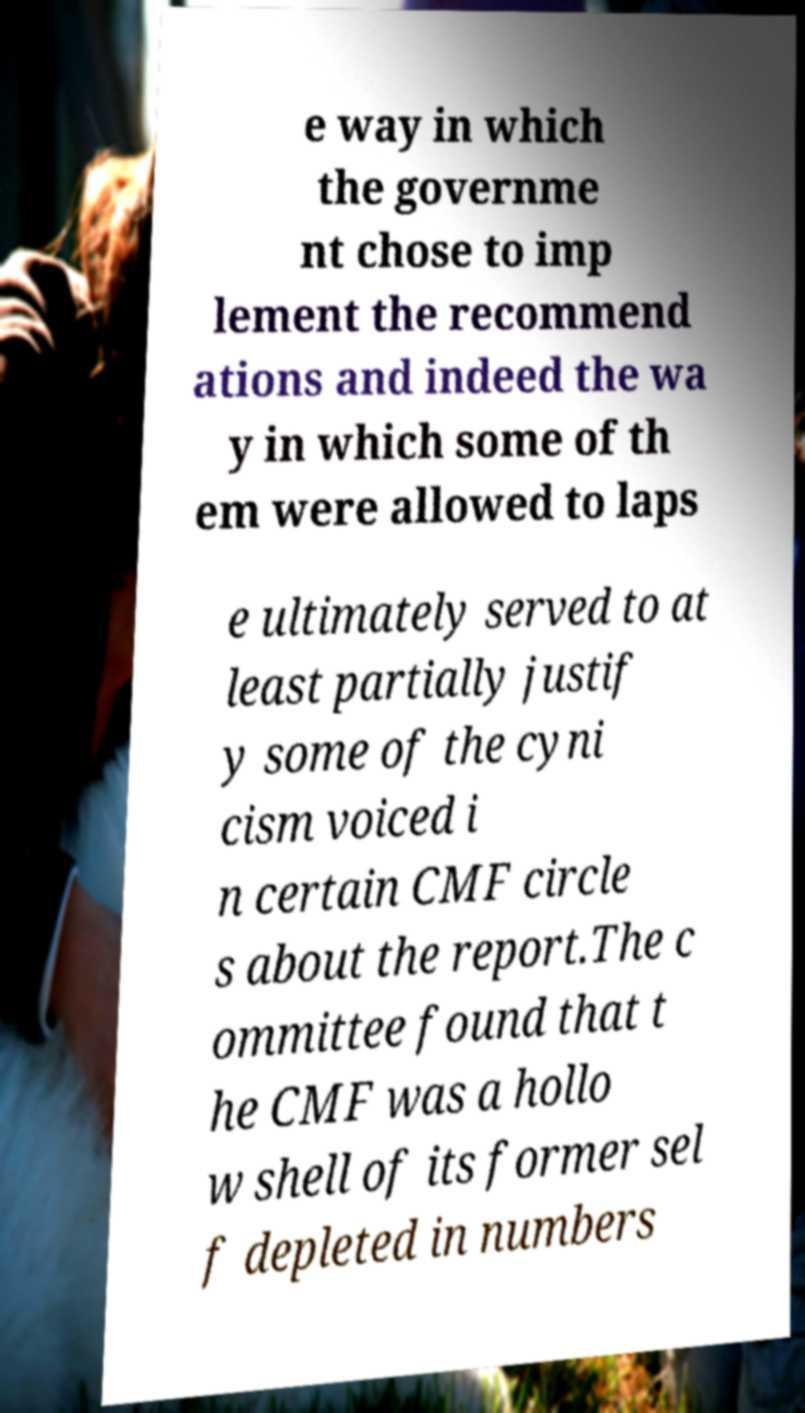There's text embedded in this image that I need extracted. Can you transcribe it verbatim? e way in which the governme nt chose to imp lement the recommend ations and indeed the wa y in which some of th em were allowed to laps e ultimately served to at least partially justif y some of the cyni cism voiced i n certain CMF circle s about the report.The c ommittee found that t he CMF was a hollo w shell of its former sel f depleted in numbers 